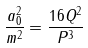<formula> <loc_0><loc_0><loc_500><loc_500>\frac { a _ { 0 } ^ { 2 } } { m ^ { 2 } } = \frac { 1 6 Q ^ { 2 } } { P ^ { 3 } }</formula> 